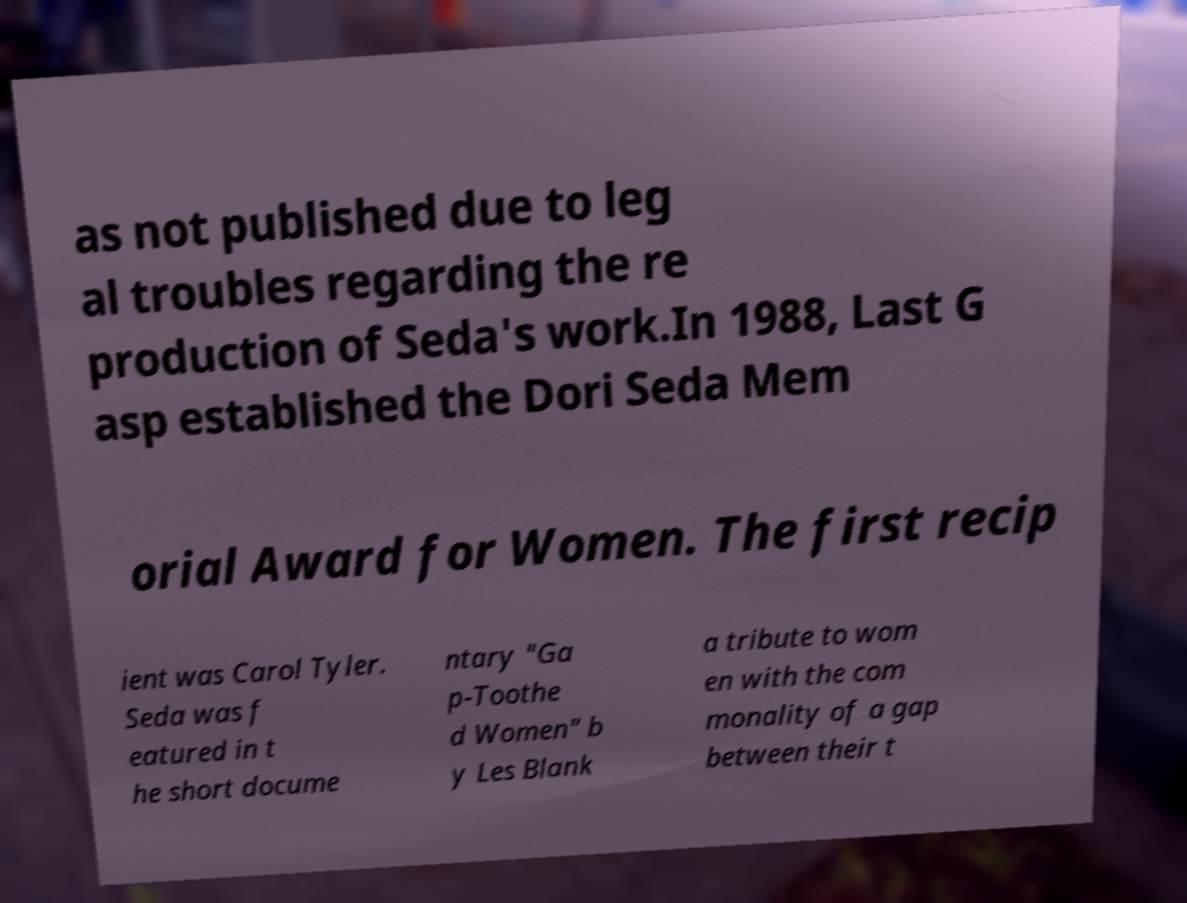Could you assist in decoding the text presented in this image and type it out clearly? as not published due to leg al troubles regarding the re production of Seda's work.In 1988, Last G asp established the Dori Seda Mem orial Award for Women. The first recip ient was Carol Tyler. Seda was f eatured in t he short docume ntary "Ga p-Toothe d Women" b y Les Blank a tribute to wom en with the com monality of a gap between their t 